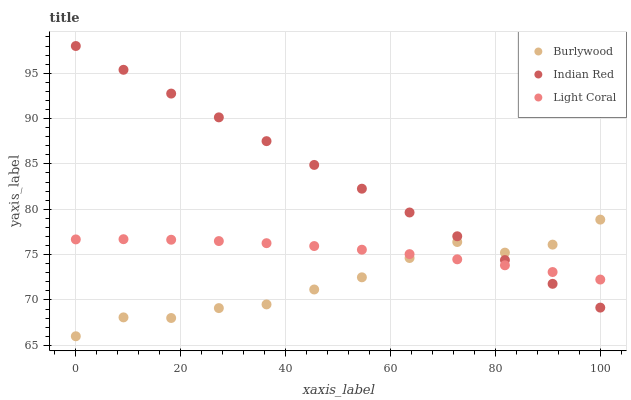Does Burlywood have the minimum area under the curve?
Answer yes or no. Yes. Does Indian Red have the maximum area under the curve?
Answer yes or no. Yes. Does Light Coral have the minimum area under the curve?
Answer yes or no. No. Does Light Coral have the maximum area under the curve?
Answer yes or no. No. Is Indian Red the smoothest?
Answer yes or no. Yes. Is Burlywood the roughest?
Answer yes or no. Yes. Is Light Coral the smoothest?
Answer yes or no. No. Is Light Coral the roughest?
Answer yes or no. No. Does Burlywood have the lowest value?
Answer yes or no. Yes. Does Indian Red have the lowest value?
Answer yes or no. No. Does Indian Red have the highest value?
Answer yes or no. Yes. Does Light Coral have the highest value?
Answer yes or no. No. Does Light Coral intersect Burlywood?
Answer yes or no. Yes. Is Light Coral less than Burlywood?
Answer yes or no. No. Is Light Coral greater than Burlywood?
Answer yes or no. No. 